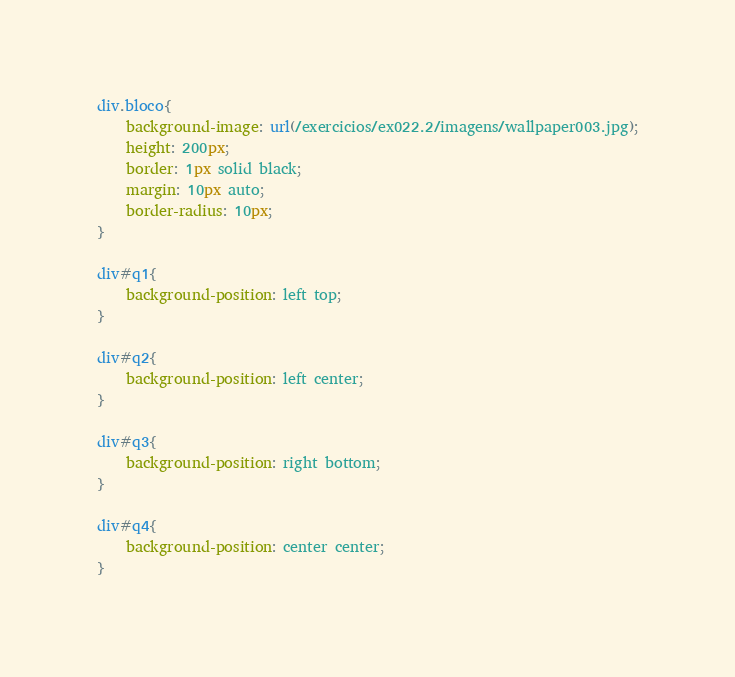Convert code to text. <code><loc_0><loc_0><loc_500><loc_500><_CSS_>div.bloco{
    background-image: url(/exercicios/ex022.2/imagens/wallpaper003.jpg);
    height: 200px;
    border: 1px solid black;
    margin: 10px auto;
    border-radius: 10px;
}

div#q1{
    background-position: left top;
}

div#q2{
    background-position: left center;
}

div#q3{
    background-position: right bottom;
}

div#q4{
    background-position: center center;
}</code> 